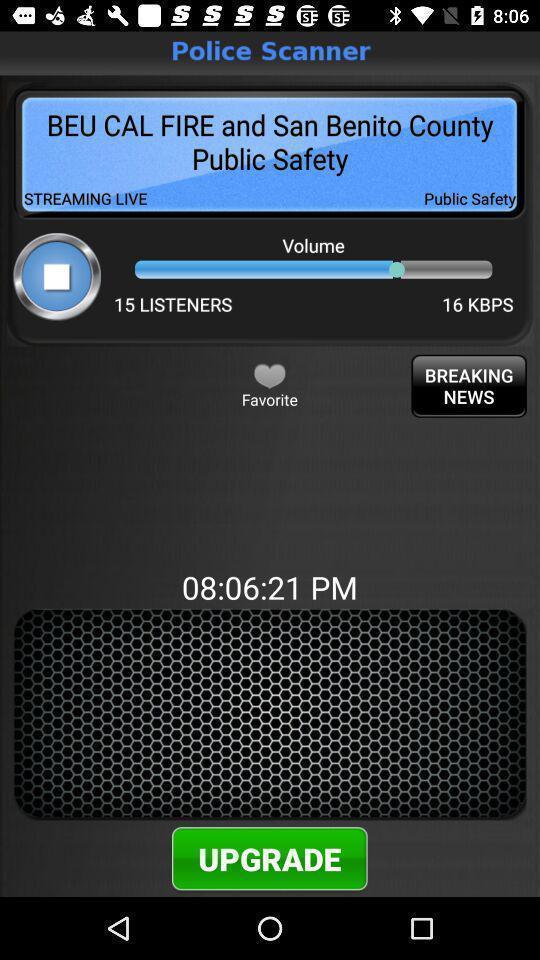Provide a textual representation of this image. Page showing volume bar and upgrading option for the application. 